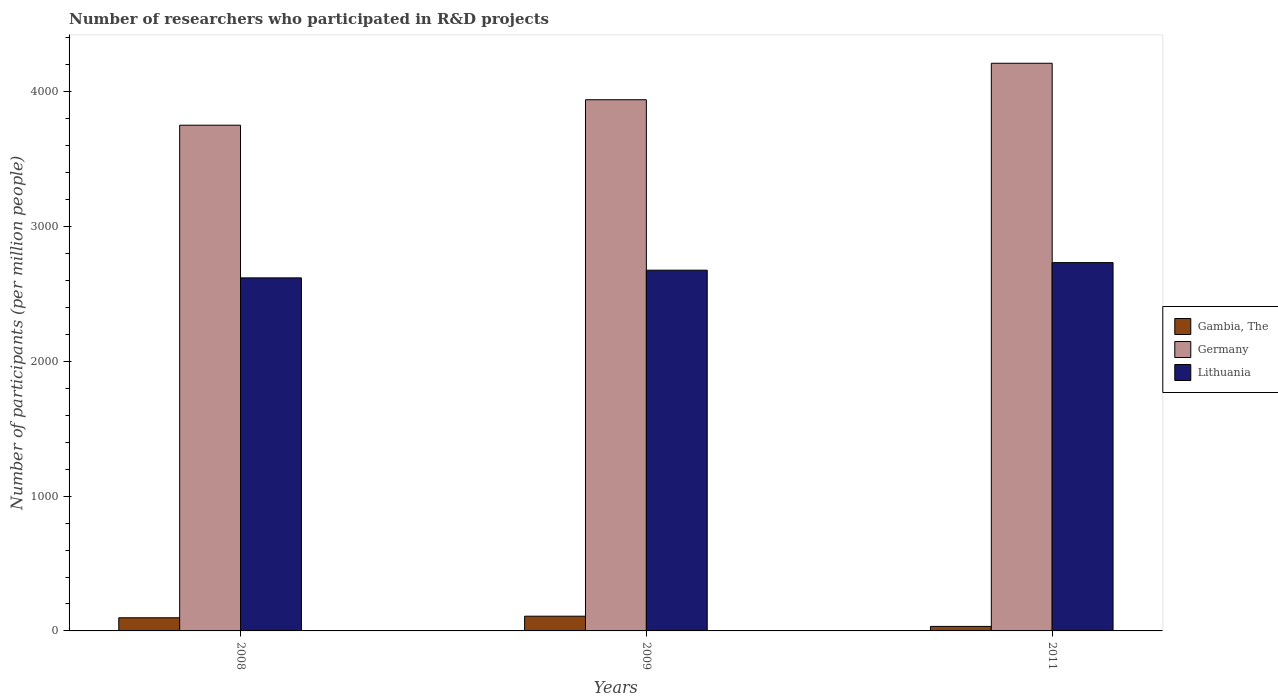How many groups of bars are there?
Give a very brief answer. 3. Are the number of bars on each tick of the X-axis equal?
Provide a succinct answer. Yes. What is the label of the 1st group of bars from the left?
Make the answer very short. 2008. In how many cases, is the number of bars for a given year not equal to the number of legend labels?
Offer a very short reply. 0. What is the number of researchers who participated in R&D projects in Gambia, The in 2009?
Your response must be concise. 109.22. Across all years, what is the maximum number of researchers who participated in R&D projects in Germany?
Keep it short and to the point. 4211.25. Across all years, what is the minimum number of researchers who participated in R&D projects in Lithuania?
Make the answer very short. 2619.11. In which year was the number of researchers who participated in R&D projects in Germany maximum?
Offer a very short reply. 2011. What is the total number of researchers who participated in R&D projects in Lithuania in the graph?
Ensure brevity in your answer.  8027.65. What is the difference between the number of researchers who participated in R&D projects in Lithuania in 2008 and that in 2011?
Give a very brief answer. -113.27. What is the difference between the number of researchers who participated in R&D projects in Lithuania in 2008 and the number of researchers who participated in R&D projects in Gambia, The in 2011?
Offer a very short reply. 2585.6. What is the average number of researchers who participated in R&D projects in Germany per year?
Your answer should be compact. 3967.92. In the year 2011, what is the difference between the number of researchers who participated in R&D projects in Gambia, The and number of researchers who participated in R&D projects in Germany?
Make the answer very short. -4177.75. What is the ratio of the number of researchers who participated in R&D projects in Gambia, The in 2009 to that in 2011?
Your answer should be compact. 3.26. What is the difference between the highest and the second highest number of researchers who participated in R&D projects in Lithuania?
Your answer should be very brief. 56.19. What is the difference between the highest and the lowest number of researchers who participated in R&D projects in Lithuania?
Make the answer very short. 113.27. In how many years, is the number of researchers who participated in R&D projects in Lithuania greater than the average number of researchers who participated in R&D projects in Lithuania taken over all years?
Give a very brief answer. 2. Is the sum of the number of researchers who participated in R&D projects in Lithuania in 2009 and 2011 greater than the maximum number of researchers who participated in R&D projects in Germany across all years?
Provide a short and direct response. Yes. What does the 2nd bar from the left in 2009 represents?
Your answer should be compact. Germany. What does the 3rd bar from the right in 2011 represents?
Provide a short and direct response. Gambia, The. Is it the case that in every year, the sum of the number of researchers who participated in R&D projects in Lithuania and number of researchers who participated in R&D projects in Germany is greater than the number of researchers who participated in R&D projects in Gambia, The?
Give a very brief answer. Yes. How many bars are there?
Provide a short and direct response. 9. What is the difference between two consecutive major ticks on the Y-axis?
Keep it short and to the point. 1000. Are the values on the major ticks of Y-axis written in scientific E-notation?
Ensure brevity in your answer.  No. Does the graph contain grids?
Offer a very short reply. No. How are the legend labels stacked?
Your response must be concise. Vertical. What is the title of the graph?
Provide a short and direct response. Number of researchers who participated in R&D projects. What is the label or title of the X-axis?
Provide a succinct answer. Years. What is the label or title of the Y-axis?
Your answer should be compact. Number of participants (per million people). What is the Number of participants (per million people) in Gambia, The in 2008?
Provide a short and direct response. 97.68. What is the Number of participants (per million people) in Germany in 2008?
Your response must be concise. 3751.78. What is the Number of participants (per million people) in Lithuania in 2008?
Offer a terse response. 2619.11. What is the Number of participants (per million people) in Gambia, The in 2009?
Offer a terse response. 109.22. What is the Number of participants (per million people) of Germany in 2009?
Ensure brevity in your answer.  3940.74. What is the Number of participants (per million people) of Lithuania in 2009?
Your answer should be very brief. 2676.18. What is the Number of participants (per million people) of Gambia, The in 2011?
Provide a succinct answer. 33.5. What is the Number of participants (per million people) of Germany in 2011?
Your answer should be compact. 4211.25. What is the Number of participants (per million people) of Lithuania in 2011?
Provide a succinct answer. 2732.37. Across all years, what is the maximum Number of participants (per million people) of Gambia, The?
Provide a short and direct response. 109.22. Across all years, what is the maximum Number of participants (per million people) in Germany?
Ensure brevity in your answer.  4211.25. Across all years, what is the maximum Number of participants (per million people) in Lithuania?
Provide a succinct answer. 2732.37. Across all years, what is the minimum Number of participants (per million people) in Gambia, The?
Provide a short and direct response. 33.5. Across all years, what is the minimum Number of participants (per million people) of Germany?
Your answer should be very brief. 3751.78. Across all years, what is the minimum Number of participants (per million people) of Lithuania?
Give a very brief answer. 2619.11. What is the total Number of participants (per million people) of Gambia, The in the graph?
Your answer should be very brief. 240.41. What is the total Number of participants (per million people) in Germany in the graph?
Offer a terse response. 1.19e+04. What is the total Number of participants (per million people) in Lithuania in the graph?
Your answer should be very brief. 8027.65. What is the difference between the Number of participants (per million people) of Gambia, The in 2008 and that in 2009?
Your answer should be compact. -11.54. What is the difference between the Number of participants (per million people) of Germany in 2008 and that in 2009?
Your answer should be very brief. -188.95. What is the difference between the Number of participants (per million people) in Lithuania in 2008 and that in 2009?
Offer a terse response. -57.07. What is the difference between the Number of participants (per million people) of Gambia, The in 2008 and that in 2011?
Provide a short and direct response. 64.18. What is the difference between the Number of participants (per million people) of Germany in 2008 and that in 2011?
Provide a short and direct response. -459.47. What is the difference between the Number of participants (per million people) of Lithuania in 2008 and that in 2011?
Provide a short and direct response. -113.27. What is the difference between the Number of participants (per million people) in Gambia, The in 2009 and that in 2011?
Your response must be concise. 75.72. What is the difference between the Number of participants (per million people) in Germany in 2009 and that in 2011?
Your response must be concise. -270.52. What is the difference between the Number of participants (per million people) of Lithuania in 2009 and that in 2011?
Offer a very short reply. -56.19. What is the difference between the Number of participants (per million people) in Gambia, The in 2008 and the Number of participants (per million people) in Germany in 2009?
Provide a succinct answer. -3843.05. What is the difference between the Number of participants (per million people) in Gambia, The in 2008 and the Number of participants (per million people) in Lithuania in 2009?
Keep it short and to the point. -2578.49. What is the difference between the Number of participants (per million people) of Germany in 2008 and the Number of participants (per million people) of Lithuania in 2009?
Provide a short and direct response. 1075.6. What is the difference between the Number of participants (per million people) of Gambia, The in 2008 and the Number of participants (per million people) of Germany in 2011?
Make the answer very short. -4113.57. What is the difference between the Number of participants (per million people) in Gambia, The in 2008 and the Number of participants (per million people) in Lithuania in 2011?
Offer a very short reply. -2634.69. What is the difference between the Number of participants (per million people) in Germany in 2008 and the Number of participants (per million people) in Lithuania in 2011?
Make the answer very short. 1019.41. What is the difference between the Number of participants (per million people) in Gambia, The in 2009 and the Number of participants (per million people) in Germany in 2011?
Provide a short and direct response. -4102.03. What is the difference between the Number of participants (per million people) of Gambia, The in 2009 and the Number of participants (per million people) of Lithuania in 2011?
Keep it short and to the point. -2623.15. What is the difference between the Number of participants (per million people) in Germany in 2009 and the Number of participants (per million people) in Lithuania in 2011?
Offer a very short reply. 1208.36. What is the average Number of participants (per million people) of Gambia, The per year?
Your answer should be very brief. 80.14. What is the average Number of participants (per million people) of Germany per year?
Ensure brevity in your answer.  3967.92. What is the average Number of participants (per million people) of Lithuania per year?
Offer a very short reply. 2675.88. In the year 2008, what is the difference between the Number of participants (per million people) of Gambia, The and Number of participants (per million people) of Germany?
Keep it short and to the point. -3654.1. In the year 2008, what is the difference between the Number of participants (per million people) of Gambia, The and Number of participants (per million people) of Lithuania?
Keep it short and to the point. -2521.42. In the year 2008, what is the difference between the Number of participants (per million people) in Germany and Number of participants (per million people) in Lithuania?
Make the answer very short. 1132.68. In the year 2009, what is the difference between the Number of participants (per million people) of Gambia, The and Number of participants (per million people) of Germany?
Your answer should be very brief. -3831.52. In the year 2009, what is the difference between the Number of participants (per million people) in Gambia, The and Number of participants (per million people) in Lithuania?
Your answer should be compact. -2566.96. In the year 2009, what is the difference between the Number of participants (per million people) of Germany and Number of participants (per million people) of Lithuania?
Provide a succinct answer. 1264.56. In the year 2011, what is the difference between the Number of participants (per million people) of Gambia, The and Number of participants (per million people) of Germany?
Your response must be concise. -4177.75. In the year 2011, what is the difference between the Number of participants (per million people) in Gambia, The and Number of participants (per million people) in Lithuania?
Offer a very short reply. -2698.87. In the year 2011, what is the difference between the Number of participants (per million people) in Germany and Number of participants (per million people) in Lithuania?
Offer a very short reply. 1478.88. What is the ratio of the Number of participants (per million people) in Gambia, The in 2008 to that in 2009?
Keep it short and to the point. 0.89. What is the ratio of the Number of participants (per million people) in Germany in 2008 to that in 2009?
Ensure brevity in your answer.  0.95. What is the ratio of the Number of participants (per million people) of Lithuania in 2008 to that in 2009?
Keep it short and to the point. 0.98. What is the ratio of the Number of participants (per million people) in Gambia, The in 2008 to that in 2011?
Your answer should be compact. 2.92. What is the ratio of the Number of participants (per million people) in Germany in 2008 to that in 2011?
Provide a short and direct response. 0.89. What is the ratio of the Number of participants (per million people) of Lithuania in 2008 to that in 2011?
Give a very brief answer. 0.96. What is the ratio of the Number of participants (per million people) in Gambia, The in 2009 to that in 2011?
Your response must be concise. 3.26. What is the ratio of the Number of participants (per million people) of Germany in 2009 to that in 2011?
Keep it short and to the point. 0.94. What is the ratio of the Number of participants (per million people) of Lithuania in 2009 to that in 2011?
Keep it short and to the point. 0.98. What is the difference between the highest and the second highest Number of participants (per million people) in Gambia, The?
Offer a very short reply. 11.54. What is the difference between the highest and the second highest Number of participants (per million people) in Germany?
Your answer should be very brief. 270.52. What is the difference between the highest and the second highest Number of participants (per million people) in Lithuania?
Your answer should be very brief. 56.19. What is the difference between the highest and the lowest Number of participants (per million people) of Gambia, The?
Your answer should be very brief. 75.72. What is the difference between the highest and the lowest Number of participants (per million people) of Germany?
Ensure brevity in your answer.  459.47. What is the difference between the highest and the lowest Number of participants (per million people) of Lithuania?
Provide a succinct answer. 113.27. 